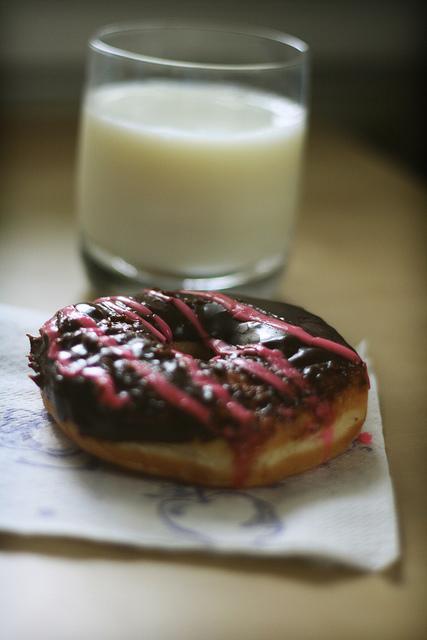Where is a napkin?
Short answer required. Under donut. Is this a chocolate donut?
Be succinct. Yes. Is the glass of milk sitting on top of the doughnut?
Quick response, please. No. 